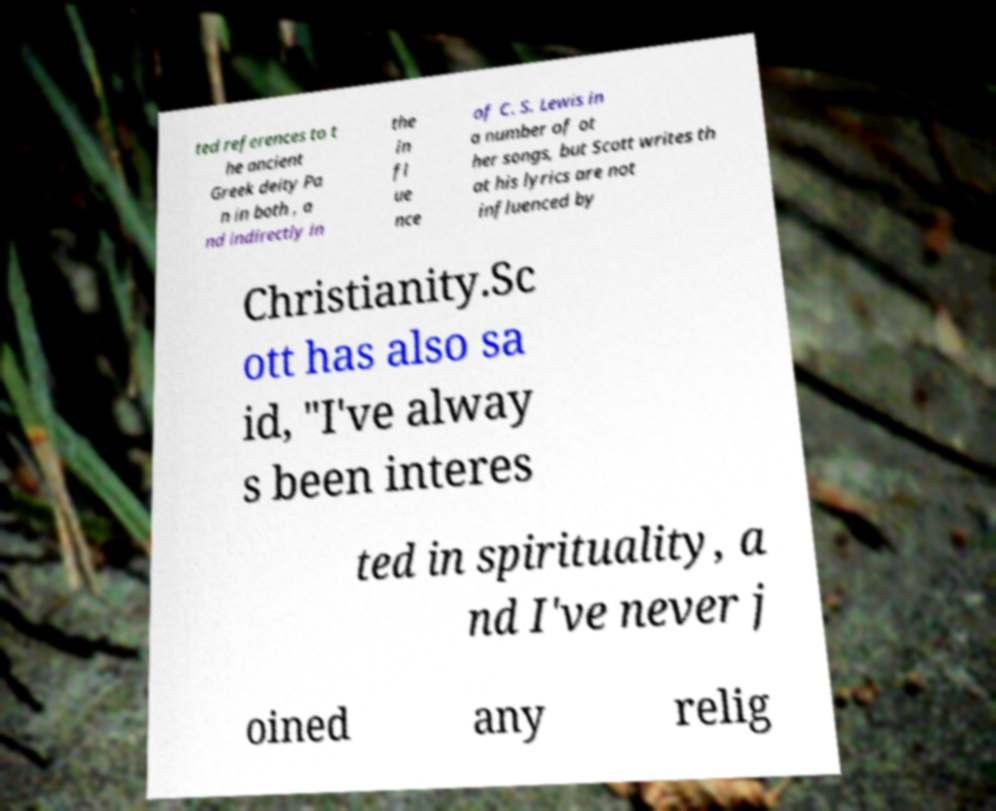Please identify and transcribe the text found in this image. ted references to t he ancient Greek deity Pa n in both , a nd indirectly in the in fl ue nce of C. S. Lewis in a number of ot her songs, but Scott writes th at his lyrics are not influenced by Christianity.Sc ott has also sa id, "I've alway s been interes ted in spirituality, a nd I've never j oined any relig 